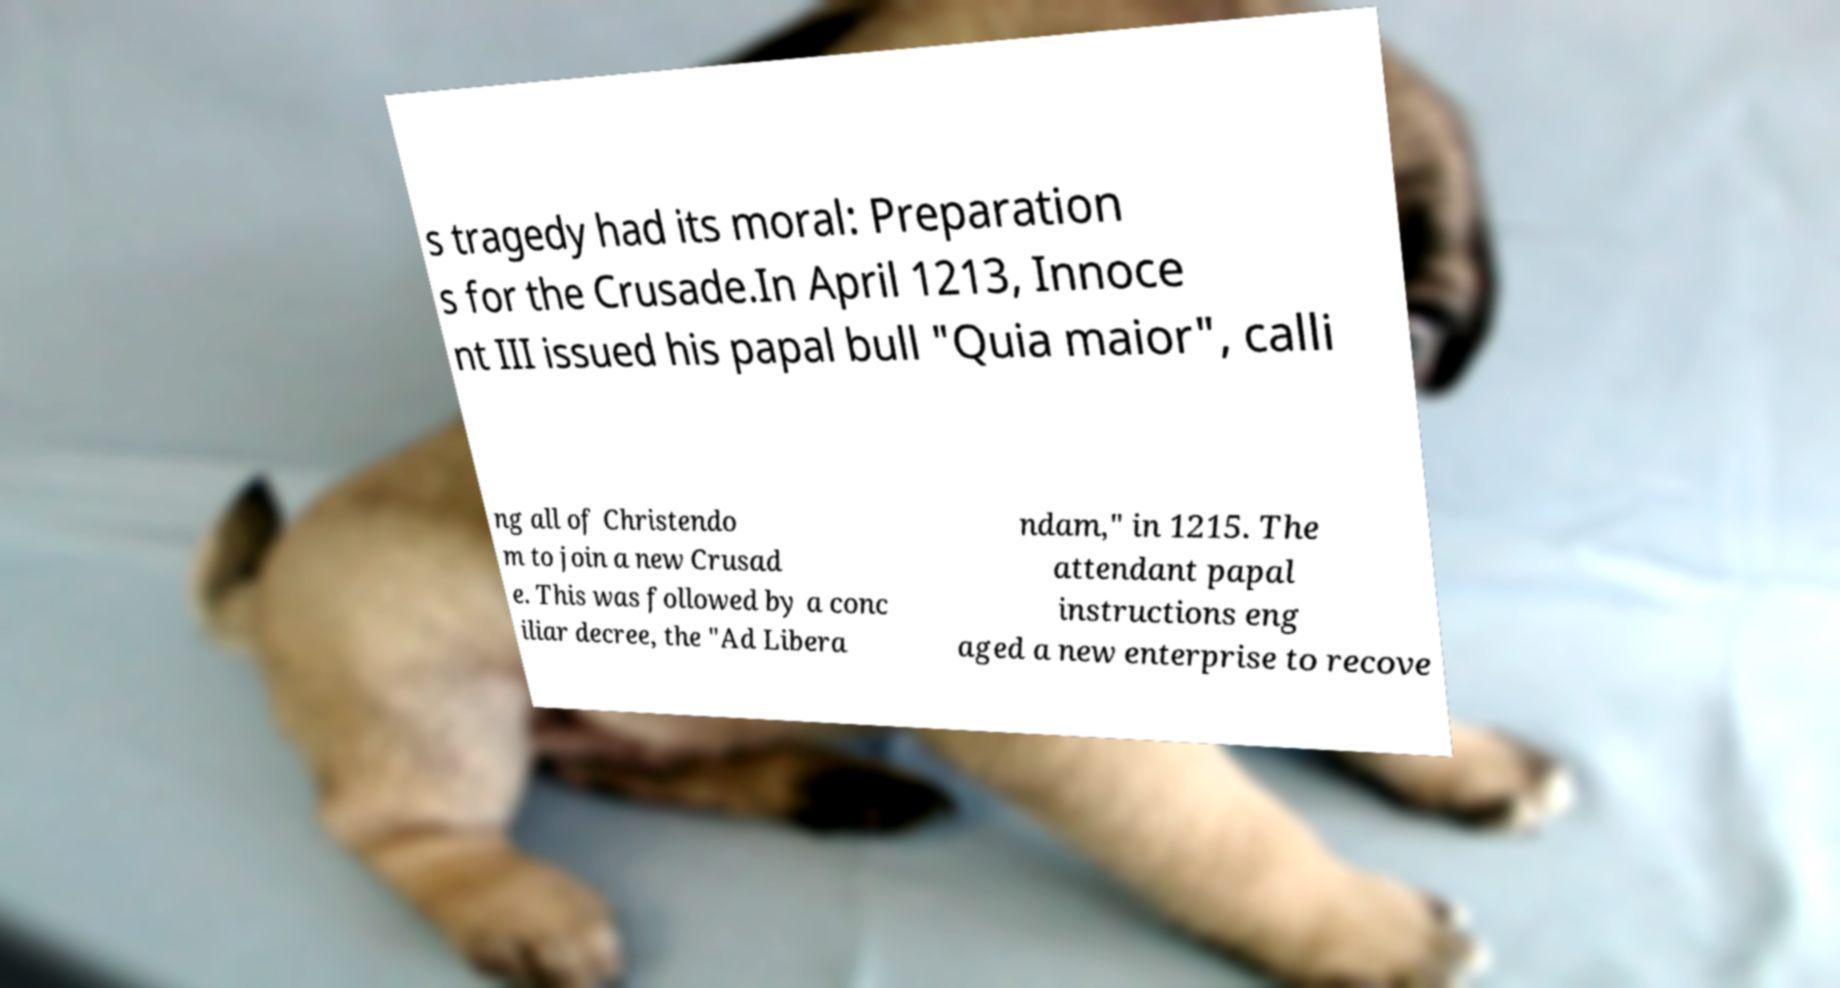What messages or text are displayed in this image? I need them in a readable, typed format. s tragedy had its moral: Preparation s for the Crusade.In April 1213, Innoce nt III issued his papal bull "Quia maior", calli ng all of Christendo m to join a new Crusad e. This was followed by a conc iliar decree, the "Ad Libera ndam," in 1215. The attendant papal instructions eng aged a new enterprise to recove 